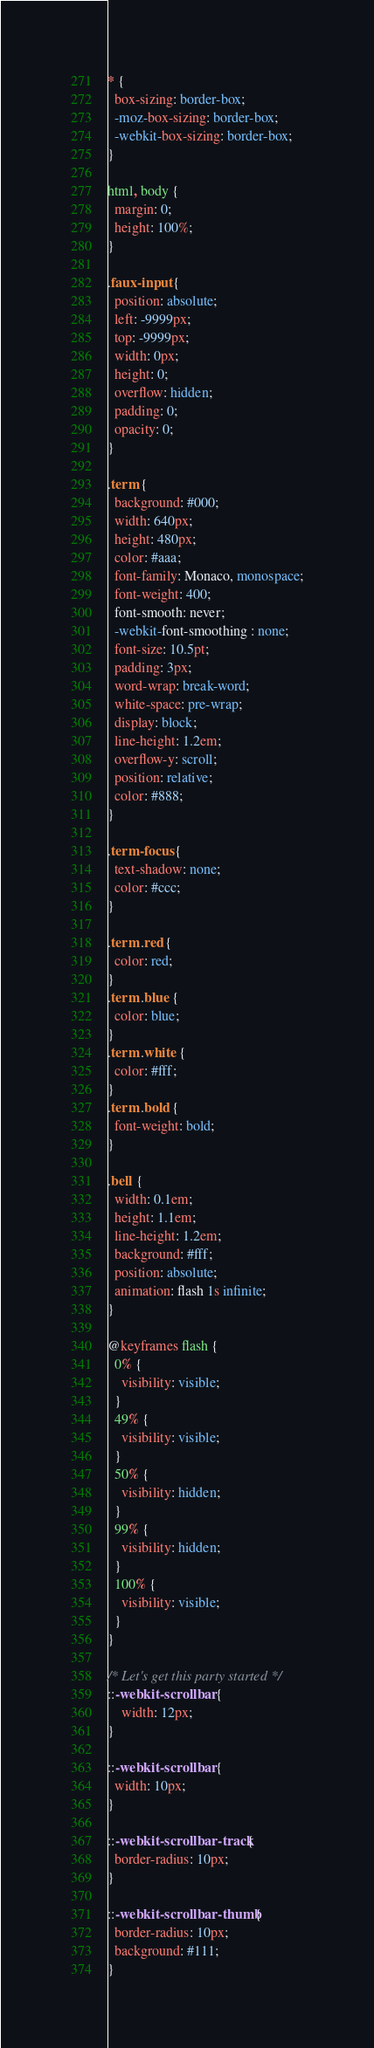Convert code to text. <code><loc_0><loc_0><loc_500><loc_500><_CSS_>* {
  box-sizing: border-box;
  -moz-box-sizing: border-box;
  -webkit-box-sizing: border-box;
}

html, body {
  margin: 0;
  height: 100%;
}

.faux-input {
  position: absolute;
  left: -9999px;
  top: -9999px;
  width: 0px;
  height: 0;
  overflow: hidden;
  padding: 0;
  opacity: 0;
}

.term {
  background: #000;
  width: 640px;
  height: 480px;
  color: #aaa;
  font-family: Monaco, monospace;
  font-weight: 400;
  font-smooth: never;
  -webkit-font-smoothing : none;
  font-size: 10.5pt;
  padding: 3px;
  word-wrap: break-word;
  white-space: pre-wrap;
  display: block;
  line-height: 1.2em;
  overflow-y: scroll;
  position: relative;
  color: #888;
}

.term-focus {
  text-shadow: none;
  color: #ccc;
}

.term .red {
  color: red;
}
.term .blue {
  color: blue;
}
.term .white {
  color: #fff;
}
.term .bold {
  font-weight: bold;
}

.bell {
  width: 0.1em;
  height: 1.1em;
  line-height: 1.2em;
  background: #fff;
  position: absolute;
  animation: flash 1s infinite;
}

@keyframes flash {
  0% {
    visibility: visible;
  }
  49% {
    visibility: visible;
  }
  50% {
    visibility: hidden;
  }
  99% {
    visibility: hidden;
  }
  100% {
    visibility: visible;
  }
}

/* Let's get this party started */
::-webkit-scrollbar {
    width: 12px;
}
 
::-webkit-scrollbar {
  width: 10px;
}
 
::-webkit-scrollbar-track {
  border-radius: 10px;
}
 
::-webkit-scrollbar-thumb {
  border-radius: 10px;
  background: #111;
}
</code> 